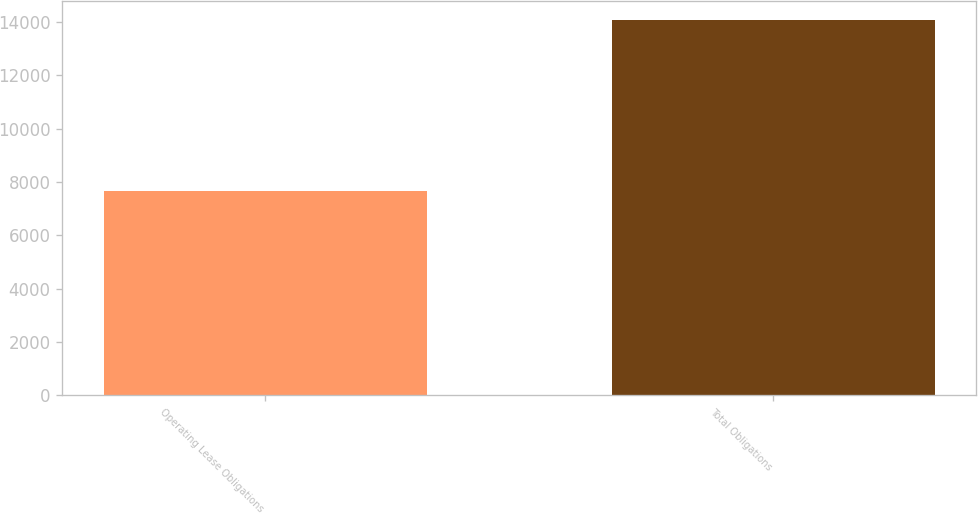<chart> <loc_0><loc_0><loc_500><loc_500><bar_chart><fcel>Operating Lease Obligations<fcel>Total Obligations<nl><fcel>7669<fcel>14090<nl></chart> 